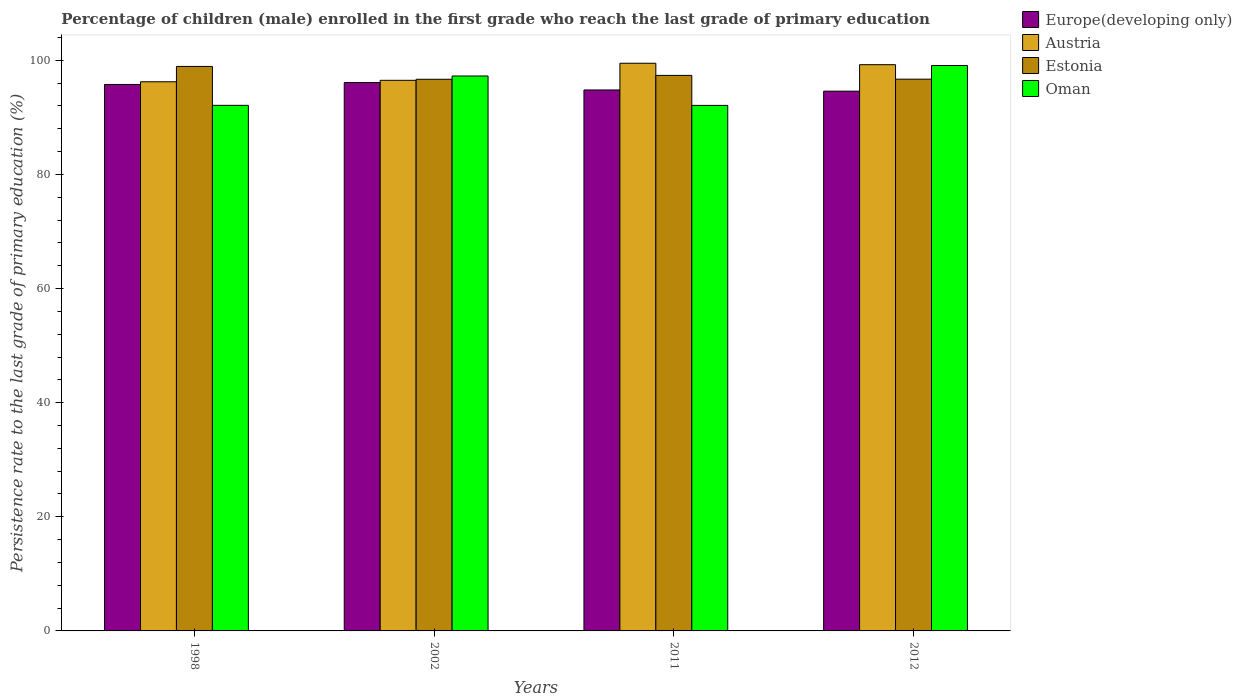How many different coloured bars are there?
Offer a terse response. 4. How many groups of bars are there?
Provide a short and direct response. 4. Are the number of bars on each tick of the X-axis equal?
Provide a short and direct response. Yes. How many bars are there on the 3rd tick from the left?
Give a very brief answer. 4. How many bars are there on the 4th tick from the right?
Give a very brief answer. 4. In how many cases, is the number of bars for a given year not equal to the number of legend labels?
Keep it short and to the point. 0. What is the persistence rate of children in Europe(developing only) in 1998?
Offer a terse response. 95.77. Across all years, what is the maximum persistence rate of children in Europe(developing only)?
Keep it short and to the point. 96.1. Across all years, what is the minimum persistence rate of children in Europe(developing only)?
Your answer should be very brief. 94.6. In which year was the persistence rate of children in Austria minimum?
Ensure brevity in your answer.  1998. What is the total persistence rate of children in Europe(developing only) in the graph?
Give a very brief answer. 381.28. What is the difference between the persistence rate of children in Estonia in 2011 and that in 2012?
Ensure brevity in your answer.  0.66. What is the difference between the persistence rate of children in Europe(developing only) in 2011 and the persistence rate of children in Oman in 2002?
Offer a very short reply. -2.45. What is the average persistence rate of children in Estonia per year?
Ensure brevity in your answer.  97.42. In the year 2012, what is the difference between the persistence rate of children in Estonia and persistence rate of children in Austria?
Give a very brief answer. -2.54. In how many years, is the persistence rate of children in Europe(developing only) greater than 68 %?
Keep it short and to the point. 4. What is the ratio of the persistence rate of children in Estonia in 1998 to that in 2011?
Make the answer very short. 1.02. Is the persistence rate of children in Europe(developing only) in 2002 less than that in 2012?
Your answer should be compact. No. Is the difference between the persistence rate of children in Estonia in 2002 and 2012 greater than the difference between the persistence rate of children in Austria in 2002 and 2012?
Offer a terse response. Yes. What is the difference between the highest and the second highest persistence rate of children in Oman?
Offer a terse response. 1.84. What is the difference between the highest and the lowest persistence rate of children in Europe(developing only)?
Offer a very short reply. 1.51. In how many years, is the persistence rate of children in Oman greater than the average persistence rate of children in Oman taken over all years?
Offer a terse response. 2. Is the sum of the persistence rate of children in Estonia in 1998 and 2012 greater than the maximum persistence rate of children in Austria across all years?
Ensure brevity in your answer.  Yes. What does the 4th bar from the left in 1998 represents?
Your answer should be very brief. Oman. What does the 1st bar from the right in 2011 represents?
Ensure brevity in your answer.  Oman. How many years are there in the graph?
Your answer should be very brief. 4. Does the graph contain any zero values?
Provide a short and direct response. No. What is the title of the graph?
Make the answer very short. Percentage of children (male) enrolled in the first grade who reach the last grade of primary education. Does "Dominica" appear as one of the legend labels in the graph?
Keep it short and to the point. No. What is the label or title of the X-axis?
Provide a succinct answer. Years. What is the label or title of the Y-axis?
Ensure brevity in your answer.  Persistence rate to the last grade of primary education (%). What is the Persistence rate to the last grade of primary education (%) in Europe(developing only) in 1998?
Keep it short and to the point. 95.77. What is the Persistence rate to the last grade of primary education (%) of Austria in 1998?
Keep it short and to the point. 96.25. What is the Persistence rate to the last grade of primary education (%) in Estonia in 1998?
Your answer should be compact. 98.93. What is the Persistence rate to the last grade of primary education (%) of Oman in 1998?
Keep it short and to the point. 92.11. What is the Persistence rate to the last grade of primary education (%) of Europe(developing only) in 2002?
Offer a terse response. 96.1. What is the Persistence rate to the last grade of primary education (%) in Austria in 2002?
Keep it short and to the point. 96.5. What is the Persistence rate to the last grade of primary education (%) of Estonia in 2002?
Provide a short and direct response. 96.68. What is the Persistence rate to the last grade of primary education (%) in Oman in 2002?
Your answer should be very brief. 97.26. What is the Persistence rate to the last grade of primary education (%) of Europe(developing only) in 2011?
Ensure brevity in your answer.  94.81. What is the Persistence rate to the last grade of primary education (%) in Austria in 2011?
Offer a very short reply. 99.49. What is the Persistence rate to the last grade of primary education (%) in Estonia in 2011?
Offer a very short reply. 97.36. What is the Persistence rate to the last grade of primary education (%) in Oman in 2011?
Give a very brief answer. 92.1. What is the Persistence rate to the last grade of primary education (%) of Europe(developing only) in 2012?
Your response must be concise. 94.6. What is the Persistence rate to the last grade of primary education (%) of Austria in 2012?
Your response must be concise. 99.24. What is the Persistence rate to the last grade of primary education (%) in Estonia in 2012?
Give a very brief answer. 96.7. What is the Persistence rate to the last grade of primary education (%) in Oman in 2012?
Ensure brevity in your answer.  99.1. Across all years, what is the maximum Persistence rate to the last grade of primary education (%) in Europe(developing only)?
Keep it short and to the point. 96.1. Across all years, what is the maximum Persistence rate to the last grade of primary education (%) of Austria?
Give a very brief answer. 99.49. Across all years, what is the maximum Persistence rate to the last grade of primary education (%) in Estonia?
Offer a terse response. 98.93. Across all years, what is the maximum Persistence rate to the last grade of primary education (%) of Oman?
Give a very brief answer. 99.1. Across all years, what is the minimum Persistence rate to the last grade of primary education (%) of Europe(developing only)?
Your response must be concise. 94.6. Across all years, what is the minimum Persistence rate to the last grade of primary education (%) of Austria?
Keep it short and to the point. 96.25. Across all years, what is the minimum Persistence rate to the last grade of primary education (%) in Estonia?
Ensure brevity in your answer.  96.68. Across all years, what is the minimum Persistence rate to the last grade of primary education (%) of Oman?
Your answer should be very brief. 92.1. What is the total Persistence rate to the last grade of primary education (%) in Europe(developing only) in the graph?
Provide a short and direct response. 381.28. What is the total Persistence rate to the last grade of primary education (%) in Austria in the graph?
Offer a very short reply. 391.48. What is the total Persistence rate to the last grade of primary education (%) in Estonia in the graph?
Provide a short and direct response. 389.68. What is the total Persistence rate to the last grade of primary education (%) of Oman in the graph?
Offer a terse response. 380.58. What is the difference between the Persistence rate to the last grade of primary education (%) of Europe(developing only) in 1998 and that in 2002?
Your answer should be compact. -0.33. What is the difference between the Persistence rate to the last grade of primary education (%) in Austria in 1998 and that in 2002?
Make the answer very short. -0.25. What is the difference between the Persistence rate to the last grade of primary education (%) in Estonia in 1998 and that in 2002?
Your response must be concise. 2.25. What is the difference between the Persistence rate to the last grade of primary education (%) of Oman in 1998 and that in 2002?
Give a very brief answer. -5.15. What is the difference between the Persistence rate to the last grade of primary education (%) of Europe(developing only) in 1998 and that in 2011?
Your answer should be very brief. 0.96. What is the difference between the Persistence rate to the last grade of primary education (%) of Austria in 1998 and that in 2011?
Your response must be concise. -3.24. What is the difference between the Persistence rate to the last grade of primary education (%) of Estonia in 1998 and that in 2011?
Your answer should be very brief. 1.57. What is the difference between the Persistence rate to the last grade of primary education (%) of Oman in 1998 and that in 2011?
Offer a very short reply. 0.01. What is the difference between the Persistence rate to the last grade of primary education (%) of Europe(developing only) in 1998 and that in 2012?
Offer a terse response. 1.17. What is the difference between the Persistence rate to the last grade of primary education (%) in Austria in 1998 and that in 2012?
Give a very brief answer. -3. What is the difference between the Persistence rate to the last grade of primary education (%) of Estonia in 1998 and that in 2012?
Offer a very short reply. 2.23. What is the difference between the Persistence rate to the last grade of primary education (%) in Oman in 1998 and that in 2012?
Your answer should be very brief. -6.98. What is the difference between the Persistence rate to the last grade of primary education (%) in Europe(developing only) in 2002 and that in 2011?
Offer a terse response. 1.29. What is the difference between the Persistence rate to the last grade of primary education (%) of Austria in 2002 and that in 2011?
Give a very brief answer. -2.99. What is the difference between the Persistence rate to the last grade of primary education (%) of Estonia in 2002 and that in 2011?
Provide a succinct answer. -0.68. What is the difference between the Persistence rate to the last grade of primary education (%) in Oman in 2002 and that in 2011?
Offer a very short reply. 5.16. What is the difference between the Persistence rate to the last grade of primary education (%) in Europe(developing only) in 2002 and that in 2012?
Keep it short and to the point. 1.51. What is the difference between the Persistence rate to the last grade of primary education (%) in Austria in 2002 and that in 2012?
Give a very brief answer. -2.74. What is the difference between the Persistence rate to the last grade of primary education (%) of Estonia in 2002 and that in 2012?
Make the answer very short. -0.02. What is the difference between the Persistence rate to the last grade of primary education (%) in Oman in 2002 and that in 2012?
Offer a very short reply. -1.84. What is the difference between the Persistence rate to the last grade of primary education (%) in Europe(developing only) in 2011 and that in 2012?
Provide a short and direct response. 0.21. What is the difference between the Persistence rate to the last grade of primary education (%) of Austria in 2011 and that in 2012?
Give a very brief answer. 0.25. What is the difference between the Persistence rate to the last grade of primary education (%) in Estonia in 2011 and that in 2012?
Keep it short and to the point. 0.66. What is the difference between the Persistence rate to the last grade of primary education (%) in Oman in 2011 and that in 2012?
Offer a terse response. -6.99. What is the difference between the Persistence rate to the last grade of primary education (%) in Europe(developing only) in 1998 and the Persistence rate to the last grade of primary education (%) in Austria in 2002?
Your answer should be very brief. -0.73. What is the difference between the Persistence rate to the last grade of primary education (%) in Europe(developing only) in 1998 and the Persistence rate to the last grade of primary education (%) in Estonia in 2002?
Your answer should be compact. -0.91. What is the difference between the Persistence rate to the last grade of primary education (%) in Europe(developing only) in 1998 and the Persistence rate to the last grade of primary education (%) in Oman in 2002?
Your response must be concise. -1.49. What is the difference between the Persistence rate to the last grade of primary education (%) of Austria in 1998 and the Persistence rate to the last grade of primary education (%) of Estonia in 2002?
Make the answer very short. -0.44. What is the difference between the Persistence rate to the last grade of primary education (%) in Austria in 1998 and the Persistence rate to the last grade of primary education (%) in Oman in 2002?
Provide a short and direct response. -1.02. What is the difference between the Persistence rate to the last grade of primary education (%) in Estonia in 1998 and the Persistence rate to the last grade of primary education (%) in Oman in 2002?
Your answer should be very brief. 1.67. What is the difference between the Persistence rate to the last grade of primary education (%) of Europe(developing only) in 1998 and the Persistence rate to the last grade of primary education (%) of Austria in 2011?
Offer a very short reply. -3.72. What is the difference between the Persistence rate to the last grade of primary education (%) of Europe(developing only) in 1998 and the Persistence rate to the last grade of primary education (%) of Estonia in 2011?
Make the answer very short. -1.59. What is the difference between the Persistence rate to the last grade of primary education (%) of Europe(developing only) in 1998 and the Persistence rate to the last grade of primary education (%) of Oman in 2011?
Keep it short and to the point. 3.67. What is the difference between the Persistence rate to the last grade of primary education (%) in Austria in 1998 and the Persistence rate to the last grade of primary education (%) in Estonia in 2011?
Ensure brevity in your answer.  -1.12. What is the difference between the Persistence rate to the last grade of primary education (%) in Austria in 1998 and the Persistence rate to the last grade of primary education (%) in Oman in 2011?
Your answer should be compact. 4.14. What is the difference between the Persistence rate to the last grade of primary education (%) of Estonia in 1998 and the Persistence rate to the last grade of primary education (%) of Oman in 2011?
Offer a terse response. 6.83. What is the difference between the Persistence rate to the last grade of primary education (%) of Europe(developing only) in 1998 and the Persistence rate to the last grade of primary education (%) of Austria in 2012?
Give a very brief answer. -3.47. What is the difference between the Persistence rate to the last grade of primary education (%) in Europe(developing only) in 1998 and the Persistence rate to the last grade of primary education (%) in Estonia in 2012?
Your response must be concise. -0.93. What is the difference between the Persistence rate to the last grade of primary education (%) of Europe(developing only) in 1998 and the Persistence rate to the last grade of primary education (%) of Oman in 2012?
Keep it short and to the point. -3.33. What is the difference between the Persistence rate to the last grade of primary education (%) of Austria in 1998 and the Persistence rate to the last grade of primary education (%) of Estonia in 2012?
Give a very brief answer. -0.46. What is the difference between the Persistence rate to the last grade of primary education (%) in Austria in 1998 and the Persistence rate to the last grade of primary education (%) in Oman in 2012?
Make the answer very short. -2.85. What is the difference between the Persistence rate to the last grade of primary education (%) in Estonia in 1998 and the Persistence rate to the last grade of primary education (%) in Oman in 2012?
Provide a short and direct response. -0.17. What is the difference between the Persistence rate to the last grade of primary education (%) in Europe(developing only) in 2002 and the Persistence rate to the last grade of primary education (%) in Austria in 2011?
Your answer should be very brief. -3.39. What is the difference between the Persistence rate to the last grade of primary education (%) of Europe(developing only) in 2002 and the Persistence rate to the last grade of primary education (%) of Estonia in 2011?
Your answer should be compact. -1.26. What is the difference between the Persistence rate to the last grade of primary education (%) in Europe(developing only) in 2002 and the Persistence rate to the last grade of primary education (%) in Oman in 2011?
Offer a very short reply. 4. What is the difference between the Persistence rate to the last grade of primary education (%) in Austria in 2002 and the Persistence rate to the last grade of primary education (%) in Estonia in 2011?
Offer a very short reply. -0.86. What is the difference between the Persistence rate to the last grade of primary education (%) of Austria in 2002 and the Persistence rate to the last grade of primary education (%) of Oman in 2011?
Your response must be concise. 4.39. What is the difference between the Persistence rate to the last grade of primary education (%) in Estonia in 2002 and the Persistence rate to the last grade of primary education (%) in Oman in 2011?
Give a very brief answer. 4.58. What is the difference between the Persistence rate to the last grade of primary education (%) of Europe(developing only) in 2002 and the Persistence rate to the last grade of primary education (%) of Austria in 2012?
Your answer should be very brief. -3.14. What is the difference between the Persistence rate to the last grade of primary education (%) of Europe(developing only) in 2002 and the Persistence rate to the last grade of primary education (%) of Estonia in 2012?
Provide a succinct answer. -0.6. What is the difference between the Persistence rate to the last grade of primary education (%) in Europe(developing only) in 2002 and the Persistence rate to the last grade of primary education (%) in Oman in 2012?
Your answer should be compact. -2.99. What is the difference between the Persistence rate to the last grade of primary education (%) in Austria in 2002 and the Persistence rate to the last grade of primary education (%) in Estonia in 2012?
Give a very brief answer. -0.2. What is the difference between the Persistence rate to the last grade of primary education (%) of Austria in 2002 and the Persistence rate to the last grade of primary education (%) of Oman in 2012?
Your answer should be compact. -2.6. What is the difference between the Persistence rate to the last grade of primary education (%) in Estonia in 2002 and the Persistence rate to the last grade of primary education (%) in Oman in 2012?
Give a very brief answer. -2.42. What is the difference between the Persistence rate to the last grade of primary education (%) in Europe(developing only) in 2011 and the Persistence rate to the last grade of primary education (%) in Austria in 2012?
Provide a succinct answer. -4.43. What is the difference between the Persistence rate to the last grade of primary education (%) in Europe(developing only) in 2011 and the Persistence rate to the last grade of primary education (%) in Estonia in 2012?
Ensure brevity in your answer.  -1.89. What is the difference between the Persistence rate to the last grade of primary education (%) in Europe(developing only) in 2011 and the Persistence rate to the last grade of primary education (%) in Oman in 2012?
Your answer should be compact. -4.29. What is the difference between the Persistence rate to the last grade of primary education (%) of Austria in 2011 and the Persistence rate to the last grade of primary education (%) of Estonia in 2012?
Offer a very short reply. 2.79. What is the difference between the Persistence rate to the last grade of primary education (%) of Austria in 2011 and the Persistence rate to the last grade of primary education (%) of Oman in 2012?
Provide a short and direct response. 0.39. What is the difference between the Persistence rate to the last grade of primary education (%) in Estonia in 2011 and the Persistence rate to the last grade of primary education (%) in Oman in 2012?
Your response must be concise. -1.74. What is the average Persistence rate to the last grade of primary education (%) of Europe(developing only) per year?
Your response must be concise. 95.32. What is the average Persistence rate to the last grade of primary education (%) of Austria per year?
Your answer should be very brief. 97.87. What is the average Persistence rate to the last grade of primary education (%) of Estonia per year?
Provide a short and direct response. 97.42. What is the average Persistence rate to the last grade of primary education (%) of Oman per year?
Offer a terse response. 95.14. In the year 1998, what is the difference between the Persistence rate to the last grade of primary education (%) in Europe(developing only) and Persistence rate to the last grade of primary education (%) in Austria?
Offer a very short reply. -0.47. In the year 1998, what is the difference between the Persistence rate to the last grade of primary education (%) of Europe(developing only) and Persistence rate to the last grade of primary education (%) of Estonia?
Keep it short and to the point. -3.16. In the year 1998, what is the difference between the Persistence rate to the last grade of primary education (%) in Europe(developing only) and Persistence rate to the last grade of primary education (%) in Oman?
Keep it short and to the point. 3.66. In the year 1998, what is the difference between the Persistence rate to the last grade of primary education (%) in Austria and Persistence rate to the last grade of primary education (%) in Estonia?
Offer a very short reply. -2.69. In the year 1998, what is the difference between the Persistence rate to the last grade of primary education (%) in Austria and Persistence rate to the last grade of primary education (%) in Oman?
Your answer should be very brief. 4.13. In the year 1998, what is the difference between the Persistence rate to the last grade of primary education (%) of Estonia and Persistence rate to the last grade of primary education (%) of Oman?
Provide a succinct answer. 6.82. In the year 2002, what is the difference between the Persistence rate to the last grade of primary education (%) in Europe(developing only) and Persistence rate to the last grade of primary education (%) in Austria?
Offer a very short reply. -0.39. In the year 2002, what is the difference between the Persistence rate to the last grade of primary education (%) in Europe(developing only) and Persistence rate to the last grade of primary education (%) in Estonia?
Your answer should be very brief. -0.58. In the year 2002, what is the difference between the Persistence rate to the last grade of primary education (%) in Europe(developing only) and Persistence rate to the last grade of primary education (%) in Oman?
Provide a succinct answer. -1.16. In the year 2002, what is the difference between the Persistence rate to the last grade of primary education (%) in Austria and Persistence rate to the last grade of primary education (%) in Estonia?
Provide a succinct answer. -0.18. In the year 2002, what is the difference between the Persistence rate to the last grade of primary education (%) in Austria and Persistence rate to the last grade of primary education (%) in Oman?
Offer a terse response. -0.76. In the year 2002, what is the difference between the Persistence rate to the last grade of primary education (%) of Estonia and Persistence rate to the last grade of primary education (%) of Oman?
Offer a terse response. -0.58. In the year 2011, what is the difference between the Persistence rate to the last grade of primary education (%) of Europe(developing only) and Persistence rate to the last grade of primary education (%) of Austria?
Your answer should be very brief. -4.68. In the year 2011, what is the difference between the Persistence rate to the last grade of primary education (%) of Europe(developing only) and Persistence rate to the last grade of primary education (%) of Estonia?
Ensure brevity in your answer.  -2.55. In the year 2011, what is the difference between the Persistence rate to the last grade of primary education (%) in Europe(developing only) and Persistence rate to the last grade of primary education (%) in Oman?
Your answer should be very brief. 2.71. In the year 2011, what is the difference between the Persistence rate to the last grade of primary education (%) in Austria and Persistence rate to the last grade of primary education (%) in Estonia?
Your answer should be very brief. 2.13. In the year 2011, what is the difference between the Persistence rate to the last grade of primary education (%) of Austria and Persistence rate to the last grade of primary education (%) of Oman?
Make the answer very short. 7.39. In the year 2011, what is the difference between the Persistence rate to the last grade of primary education (%) of Estonia and Persistence rate to the last grade of primary education (%) of Oman?
Your answer should be compact. 5.26. In the year 2012, what is the difference between the Persistence rate to the last grade of primary education (%) of Europe(developing only) and Persistence rate to the last grade of primary education (%) of Austria?
Your answer should be compact. -4.64. In the year 2012, what is the difference between the Persistence rate to the last grade of primary education (%) of Europe(developing only) and Persistence rate to the last grade of primary education (%) of Estonia?
Provide a short and direct response. -2.1. In the year 2012, what is the difference between the Persistence rate to the last grade of primary education (%) of Europe(developing only) and Persistence rate to the last grade of primary education (%) of Oman?
Provide a short and direct response. -4.5. In the year 2012, what is the difference between the Persistence rate to the last grade of primary education (%) of Austria and Persistence rate to the last grade of primary education (%) of Estonia?
Your answer should be compact. 2.54. In the year 2012, what is the difference between the Persistence rate to the last grade of primary education (%) of Austria and Persistence rate to the last grade of primary education (%) of Oman?
Provide a succinct answer. 0.14. In the year 2012, what is the difference between the Persistence rate to the last grade of primary education (%) of Estonia and Persistence rate to the last grade of primary education (%) of Oman?
Provide a short and direct response. -2.4. What is the ratio of the Persistence rate to the last grade of primary education (%) in Europe(developing only) in 1998 to that in 2002?
Your answer should be very brief. 1. What is the ratio of the Persistence rate to the last grade of primary education (%) of Estonia in 1998 to that in 2002?
Your answer should be very brief. 1.02. What is the ratio of the Persistence rate to the last grade of primary education (%) of Oman in 1998 to that in 2002?
Provide a short and direct response. 0.95. What is the ratio of the Persistence rate to the last grade of primary education (%) in Europe(developing only) in 1998 to that in 2011?
Provide a succinct answer. 1.01. What is the ratio of the Persistence rate to the last grade of primary education (%) of Austria in 1998 to that in 2011?
Your response must be concise. 0.97. What is the ratio of the Persistence rate to the last grade of primary education (%) in Estonia in 1998 to that in 2011?
Offer a very short reply. 1.02. What is the ratio of the Persistence rate to the last grade of primary education (%) of Oman in 1998 to that in 2011?
Your answer should be very brief. 1. What is the ratio of the Persistence rate to the last grade of primary education (%) in Europe(developing only) in 1998 to that in 2012?
Offer a very short reply. 1.01. What is the ratio of the Persistence rate to the last grade of primary education (%) in Austria in 1998 to that in 2012?
Ensure brevity in your answer.  0.97. What is the ratio of the Persistence rate to the last grade of primary education (%) of Estonia in 1998 to that in 2012?
Give a very brief answer. 1.02. What is the ratio of the Persistence rate to the last grade of primary education (%) of Oman in 1998 to that in 2012?
Your response must be concise. 0.93. What is the ratio of the Persistence rate to the last grade of primary education (%) of Europe(developing only) in 2002 to that in 2011?
Offer a terse response. 1.01. What is the ratio of the Persistence rate to the last grade of primary education (%) of Austria in 2002 to that in 2011?
Your answer should be compact. 0.97. What is the ratio of the Persistence rate to the last grade of primary education (%) in Oman in 2002 to that in 2011?
Offer a very short reply. 1.06. What is the ratio of the Persistence rate to the last grade of primary education (%) of Europe(developing only) in 2002 to that in 2012?
Make the answer very short. 1.02. What is the ratio of the Persistence rate to the last grade of primary education (%) of Austria in 2002 to that in 2012?
Offer a very short reply. 0.97. What is the ratio of the Persistence rate to the last grade of primary education (%) of Estonia in 2002 to that in 2012?
Provide a short and direct response. 1. What is the ratio of the Persistence rate to the last grade of primary education (%) in Oman in 2002 to that in 2012?
Ensure brevity in your answer.  0.98. What is the ratio of the Persistence rate to the last grade of primary education (%) of Europe(developing only) in 2011 to that in 2012?
Your response must be concise. 1. What is the ratio of the Persistence rate to the last grade of primary education (%) of Estonia in 2011 to that in 2012?
Offer a terse response. 1.01. What is the ratio of the Persistence rate to the last grade of primary education (%) in Oman in 2011 to that in 2012?
Offer a terse response. 0.93. What is the difference between the highest and the second highest Persistence rate to the last grade of primary education (%) in Europe(developing only)?
Keep it short and to the point. 0.33. What is the difference between the highest and the second highest Persistence rate to the last grade of primary education (%) in Austria?
Ensure brevity in your answer.  0.25. What is the difference between the highest and the second highest Persistence rate to the last grade of primary education (%) of Estonia?
Make the answer very short. 1.57. What is the difference between the highest and the second highest Persistence rate to the last grade of primary education (%) of Oman?
Ensure brevity in your answer.  1.84. What is the difference between the highest and the lowest Persistence rate to the last grade of primary education (%) of Europe(developing only)?
Make the answer very short. 1.51. What is the difference between the highest and the lowest Persistence rate to the last grade of primary education (%) in Austria?
Make the answer very short. 3.24. What is the difference between the highest and the lowest Persistence rate to the last grade of primary education (%) of Estonia?
Your answer should be compact. 2.25. What is the difference between the highest and the lowest Persistence rate to the last grade of primary education (%) in Oman?
Ensure brevity in your answer.  6.99. 